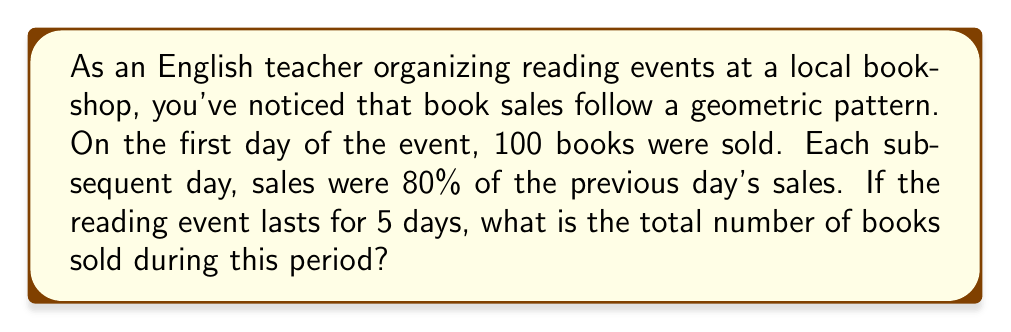Teach me how to tackle this problem. To solve this problem, we need to use the formula for the sum of a geometric series:

$$S_n = \frac{a(1-r^n)}{1-r}$$

Where:
$S_n$ = Sum of the series
$a$ = First term
$r$ = Common ratio
$n$ = Number of terms

Let's identify these components:

1. $a = 100$ (first day's sales)
2. $r = 0.8$ (each day's sales are 80% of the previous day)
3. $n = 5$ (5-day event)

Now, let's substitute these values into our formula:

$$S_5 = \frac{100(1-0.8^5)}{1-0.8}$$

Simplifying:

1. Calculate $0.8^5 = 0.32768$
2. Subtract from 1: $1 - 0.32768 = 0.67232$
3. Multiply by 100: $100 * 0.67232 = 67.232$
4. Divide by $1-0.8 = 0.2$:
   
   $$\frac{67.232}{0.2} = 336.16$$

Therefore, the total number of books sold over the 5-day period is 336.16, which we round to 336 since we can't sell a fraction of a book.
Answer: 336 books 